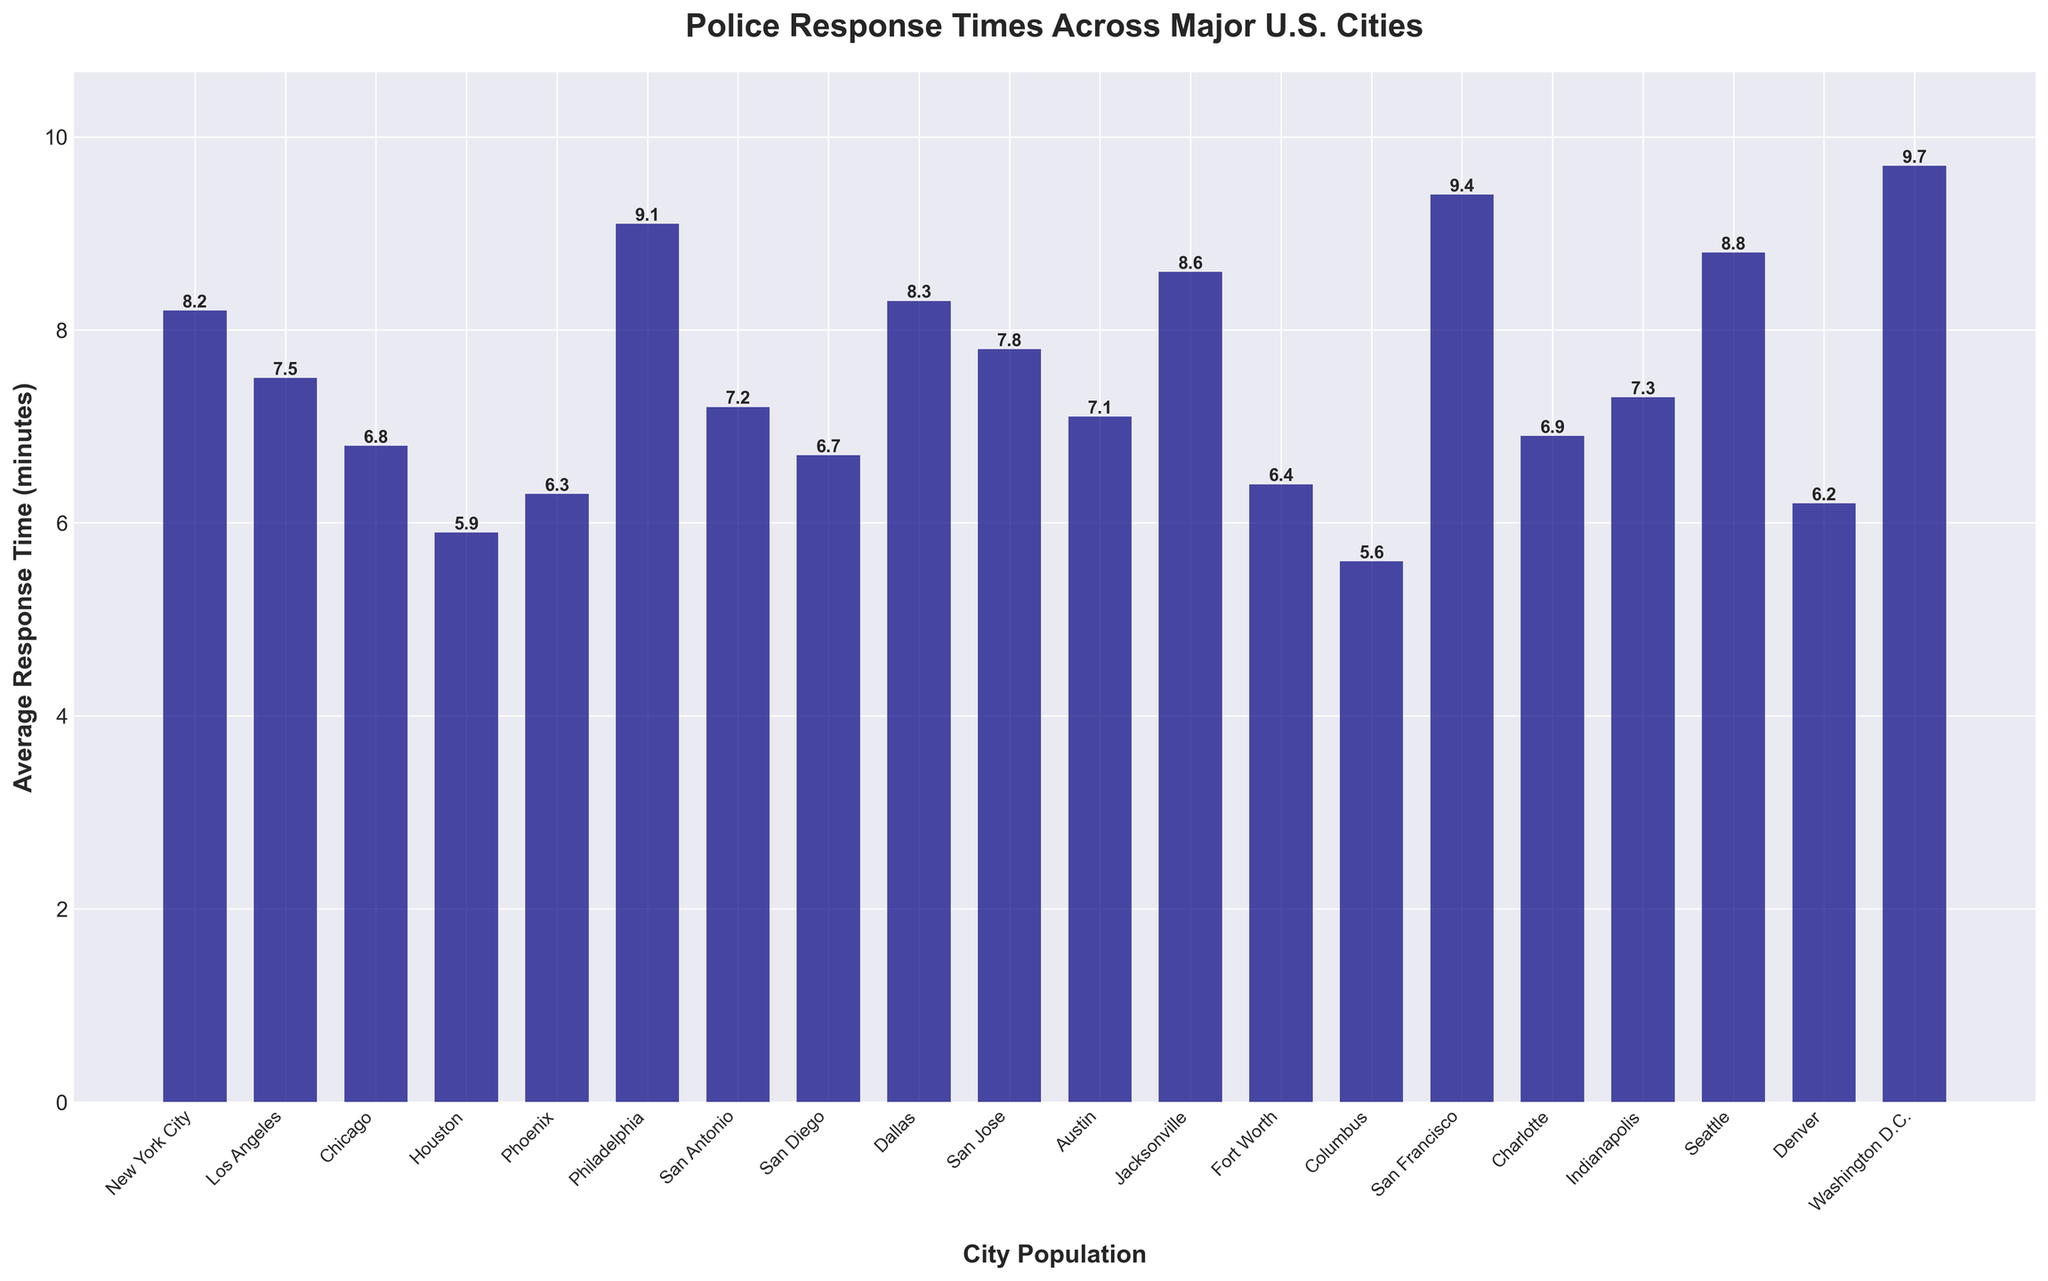What is the city with the fastest police response time? To find the city with the fastest police response time, we need to identify the bar with the lowest height. In the plot, Columbus has the lowest bar indicating a response time of 5.6 minutes.
Answer: Columbus What is the difference in police response time between New York City and Houston? First, find the response times for New York City (8.2 minutes) and Houston (5.9 minutes). Then, subtract Houston's time from New York City's time: 8.2 - 5.9 = 2.3 minutes.
Answer: 2.3 minutes How many cities have a police response time greater than 9 minutes? Look for bars that have heights exceeding 9 minutes. There are three cities: Philadelphia (9.1), San Francisco (9.4), and Washington D.C. (9.7).
Answer: 3 cities What is the average police response time for all cities? Sum all the response times and divide by the number of cities: (8.2 + 7.5 + 6.8 + 5.9 + 6.3 + 9.1 + 7.2 + 6.7 + 8.3 + 7.8 + 7.1 + 8.6 + 6.4 + 5.6 + 9.4 + 6.9 + 7.3 + 8.8 + 6.2 + 9.7)/20. This results in 153.8/20 = 7.69 minutes.
Answer: 7.69 minutes Which city has a police response time closest to the overall average response time for all cities? Calculate the overall average response time as found previously (7.69 minutes). Check each city’s response time to find the one closest to this value. San Jose, with a response time of 7.8 minutes, is the closest.
Answer: San Jose Which city has the slowest police response time? Identify the bar with the highest height. Washington D.C. has the highest bar, indicating the slowest response time at 9.7 minutes.
Answer: Washington D.C Is Dallas' police response time greater than San Diego's? Compare the bars for Dallas and San Diego. Dallas has a response time of 8.3 minutes, while San Diego has 6.7 minutes. Since 8.3 is greater than 6.7, Dallas' response time is indeed greater.
Answer: Yes What is the median police response time? To find the median, first sort the response times in ascending order: 5.6, 5.9, 6.2, 6.3, 6.4, 6.7, 6.8, 6.9, 7.1, 7.2, 7.3, 7.5, 7.8, 8.2, 8.3, 8.6, 8.8, 9.1, 9.4, 9.7. The median value, being the middle value of this sorted list, is the average of the 10th and 11th values: (7.2 + 7.3) / 2 = 7.25 minutes.
Answer: 7.25 minutes 